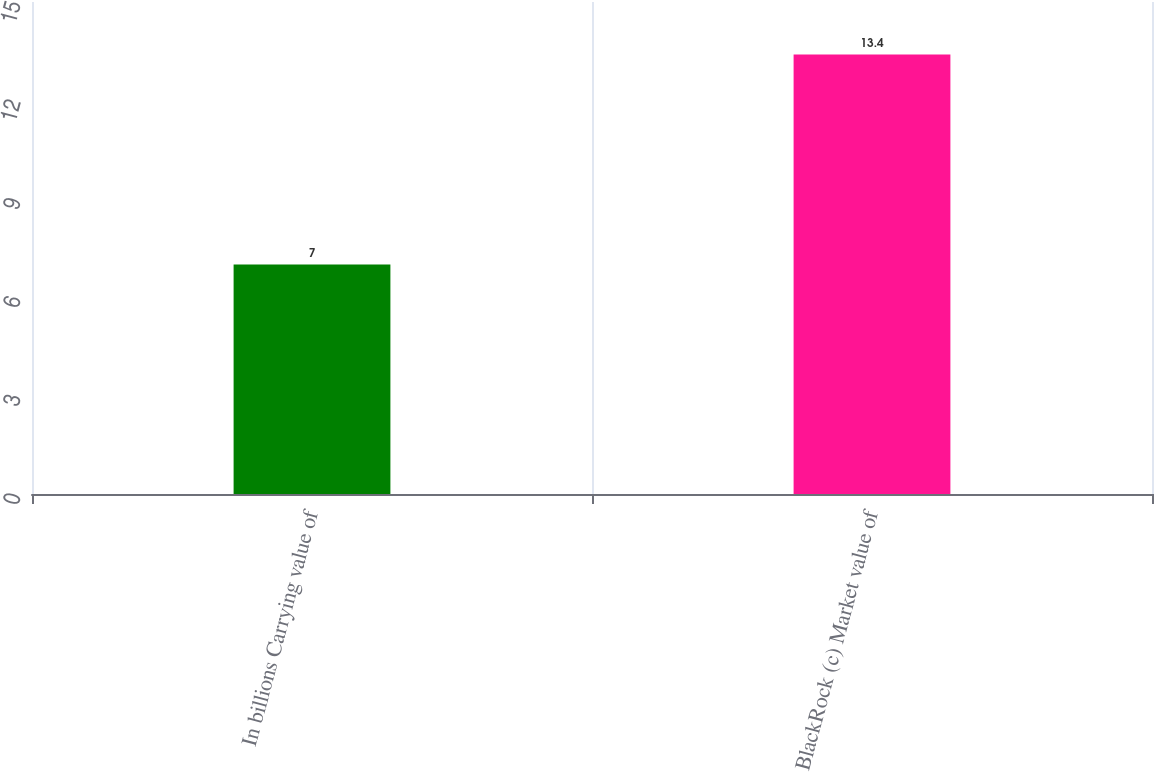<chart> <loc_0><loc_0><loc_500><loc_500><bar_chart><fcel>In billions Carrying value of<fcel>BlackRock (c) Market value of<nl><fcel>7<fcel>13.4<nl></chart> 